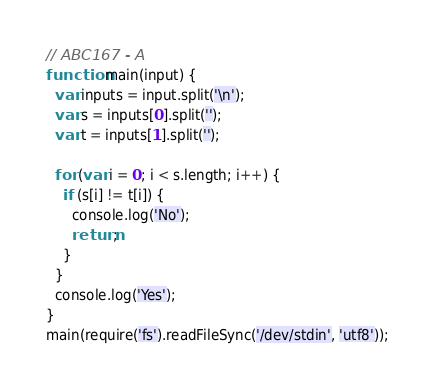<code> <loc_0><loc_0><loc_500><loc_500><_JavaScript_>// ABC167 - A
function main(input) {
  var inputs = input.split('\n');
  var s = inputs[0].split('');
  var t = inputs[1].split('');

  for (var i = 0; i < s.length; i++) {
    if (s[i] != t[i]) {
      console.log('No');
      return;
    }
  }
  console.log('Yes');
}
main(require('fs').readFileSync('/dev/stdin', 'utf8'));
</code> 